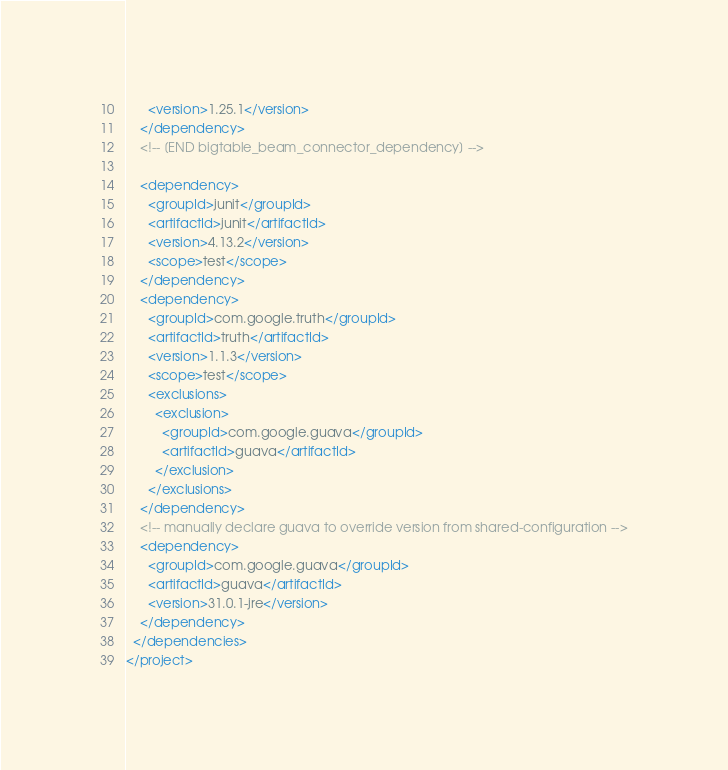<code> <loc_0><loc_0><loc_500><loc_500><_XML_>      <version>1.25.1</version>
    </dependency>
    <!-- [END bigtable_beam_connector_dependency] -->

    <dependency>
      <groupId>junit</groupId>
      <artifactId>junit</artifactId>
      <version>4.13.2</version>
      <scope>test</scope>
    </dependency>
    <dependency>
      <groupId>com.google.truth</groupId>
      <artifactId>truth</artifactId>
      <version>1.1.3</version>
      <scope>test</scope>
      <exclusions>
        <exclusion>
          <groupId>com.google.guava</groupId>
          <artifactId>guava</artifactId>
        </exclusion>
      </exclusions>
    </dependency>
    <!-- manually declare guava to override version from shared-configuration -->
    <dependency>
      <groupId>com.google.guava</groupId>
      <artifactId>guava</artifactId>
      <version>31.0.1-jre</version>
    </dependency>
  </dependencies>
</project></code> 